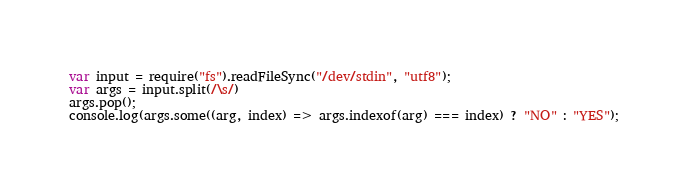<code> <loc_0><loc_0><loc_500><loc_500><_JavaScript_>var input = require("fs").readFileSync("/dev/stdin", "utf8");
var args = input.split(/\s/)
args.pop();
console.log(args.some((arg, index) => args.indexof(arg) === index) ? "NO" : "YES");</code> 